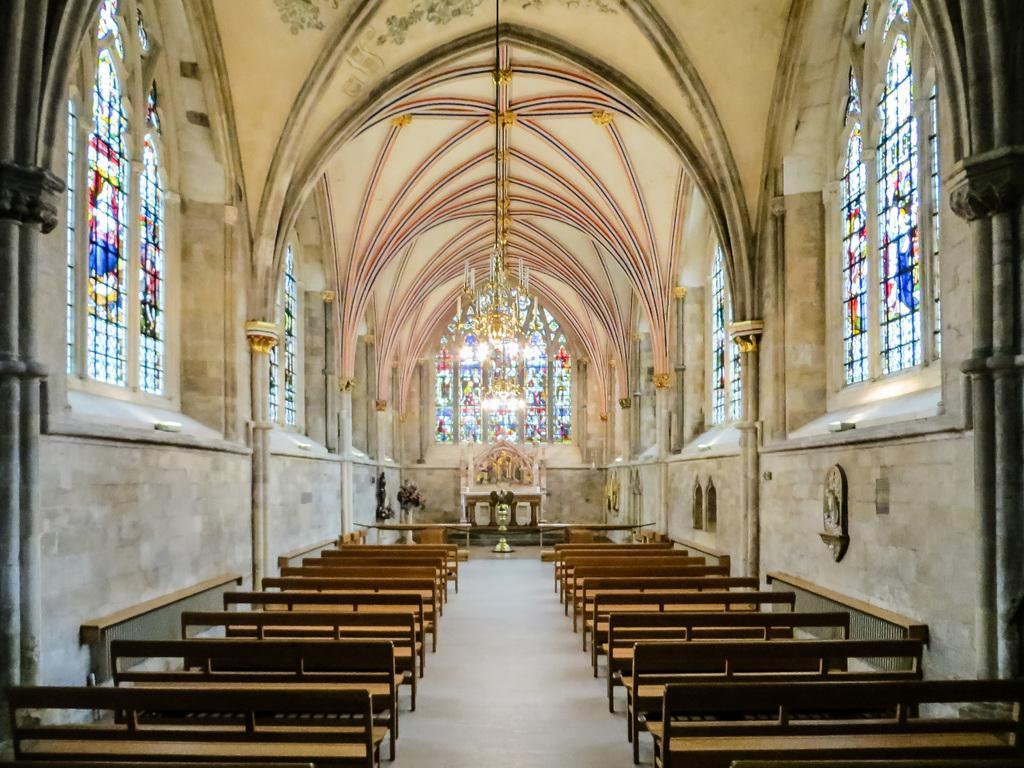In one or two sentences, can you explain what this image depicts? The picture is taken inside a church. In the foreground of the picture there are benches and pillars. On the right there are windows. On the left there are windows. At the top it is roof. In the center of the background there are table, chandelier, window and other objects. 